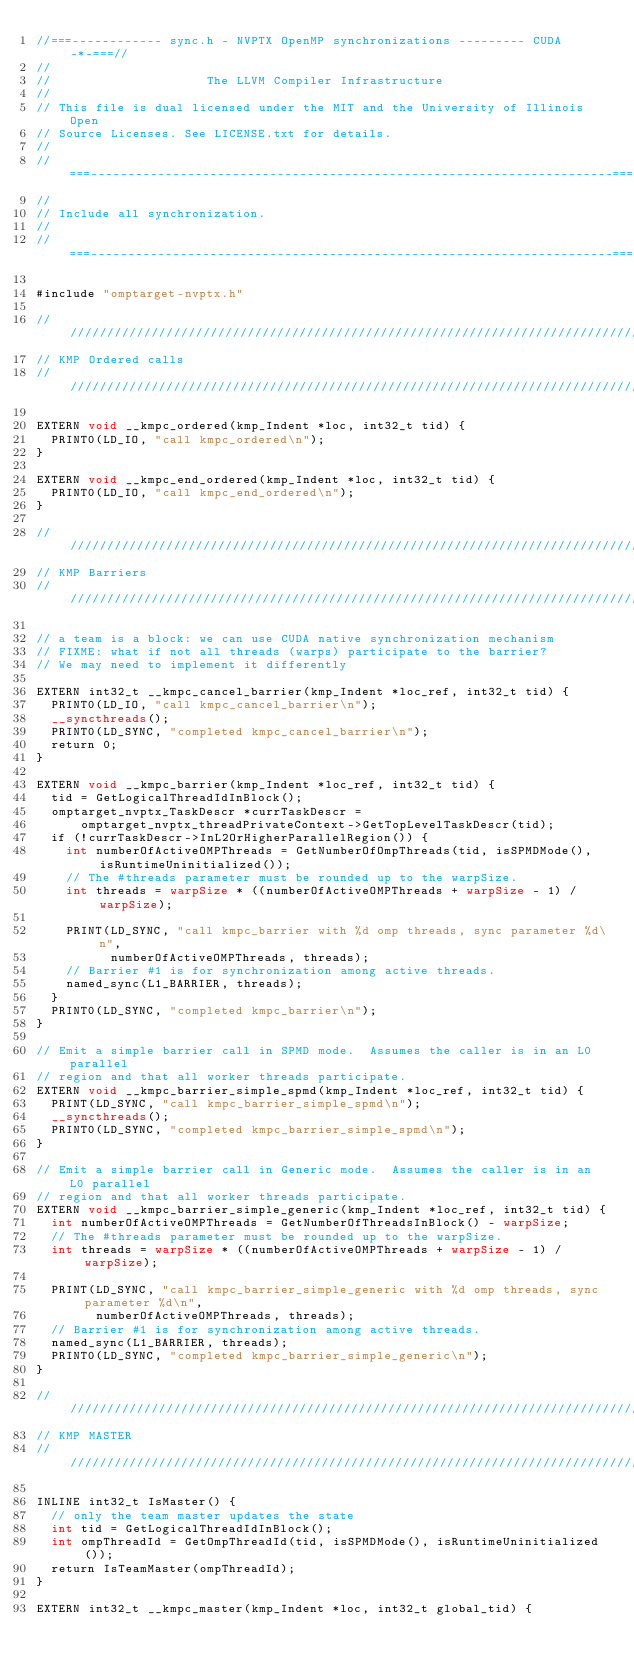<code> <loc_0><loc_0><loc_500><loc_500><_Cuda_>//===------------ sync.h - NVPTX OpenMP synchronizations --------- CUDA -*-===//
//
//                     The LLVM Compiler Infrastructure
//
// This file is dual licensed under the MIT and the University of Illinois Open
// Source Licenses. See LICENSE.txt for details.
//
//===----------------------------------------------------------------------===//
//
// Include all synchronization.
//
//===----------------------------------------------------------------------===//

#include "omptarget-nvptx.h"

////////////////////////////////////////////////////////////////////////////////
// KMP Ordered calls
////////////////////////////////////////////////////////////////////////////////

EXTERN void __kmpc_ordered(kmp_Indent *loc, int32_t tid) {
  PRINT0(LD_IO, "call kmpc_ordered\n");
}

EXTERN void __kmpc_end_ordered(kmp_Indent *loc, int32_t tid) {
  PRINT0(LD_IO, "call kmpc_end_ordered\n");
}

////////////////////////////////////////////////////////////////////////////////
// KMP Barriers
////////////////////////////////////////////////////////////////////////////////

// a team is a block: we can use CUDA native synchronization mechanism
// FIXME: what if not all threads (warps) participate to the barrier?
// We may need to implement it differently

EXTERN int32_t __kmpc_cancel_barrier(kmp_Indent *loc_ref, int32_t tid) {
  PRINT0(LD_IO, "call kmpc_cancel_barrier\n");
  __syncthreads();
  PRINT0(LD_SYNC, "completed kmpc_cancel_barrier\n");
  return 0;
}

EXTERN void __kmpc_barrier(kmp_Indent *loc_ref, int32_t tid) {
  tid = GetLogicalThreadIdInBlock();
  omptarget_nvptx_TaskDescr *currTaskDescr =
      omptarget_nvptx_threadPrivateContext->GetTopLevelTaskDescr(tid);
  if (!currTaskDescr->InL2OrHigherParallelRegion()) {
    int numberOfActiveOMPThreads = GetNumberOfOmpThreads(tid, isSPMDMode(), isRuntimeUninitialized());
    // The #threads parameter must be rounded up to the warpSize.
    int threads = warpSize * ((numberOfActiveOMPThreads + warpSize - 1) / warpSize);

    PRINT(LD_SYNC, "call kmpc_barrier with %d omp threads, sync parameter %d\n",
          numberOfActiveOMPThreads, threads);
    // Barrier #1 is for synchronization among active threads.
    named_sync(L1_BARRIER, threads);
  }
  PRINT0(LD_SYNC, "completed kmpc_barrier\n");
}

// Emit a simple barrier call in SPMD mode.  Assumes the caller is in an L0 parallel
// region and that all worker threads participate.
EXTERN void __kmpc_barrier_simple_spmd(kmp_Indent *loc_ref, int32_t tid) {
  PRINT(LD_SYNC, "call kmpc_barrier_simple_spmd\n");
  __syncthreads();
  PRINT0(LD_SYNC, "completed kmpc_barrier_simple_spmd\n");
}

// Emit a simple barrier call in Generic mode.  Assumes the caller is in an L0 parallel
// region and that all worker threads participate.
EXTERN void __kmpc_barrier_simple_generic(kmp_Indent *loc_ref, int32_t tid) {
  int numberOfActiveOMPThreads = GetNumberOfThreadsInBlock() - warpSize;
  // The #threads parameter must be rounded up to the warpSize.
  int threads = warpSize * ((numberOfActiveOMPThreads + warpSize - 1) / warpSize);

  PRINT(LD_SYNC, "call kmpc_barrier_simple_generic with %d omp threads, sync parameter %d\n",
        numberOfActiveOMPThreads, threads);
  // Barrier #1 is for synchronization among active threads.
  named_sync(L1_BARRIER, threads);
  PRINT0(LD_SYNC, "completed kmpc_barrier_simple_generic\n");
}

////////////////////////////////////////////////////////////////////////////////
// KMP MASTER
////////////////////////////////////////////////////////////////////////////////

INLINE int32_t IsMaster() {
  // only the team master updates the state
  int tid = GetLogicalThreadIdInBlock();
  int ompThreadId = GetOmpThreadId(tid, isSPMDMode(), isRuntimeUninitialized());
  return IsTeamMaster(ompThreadId);
}

EXTERN int32_t __kmpc_master(kmp_Indent *loc, int32_t global_tid) {</code> 